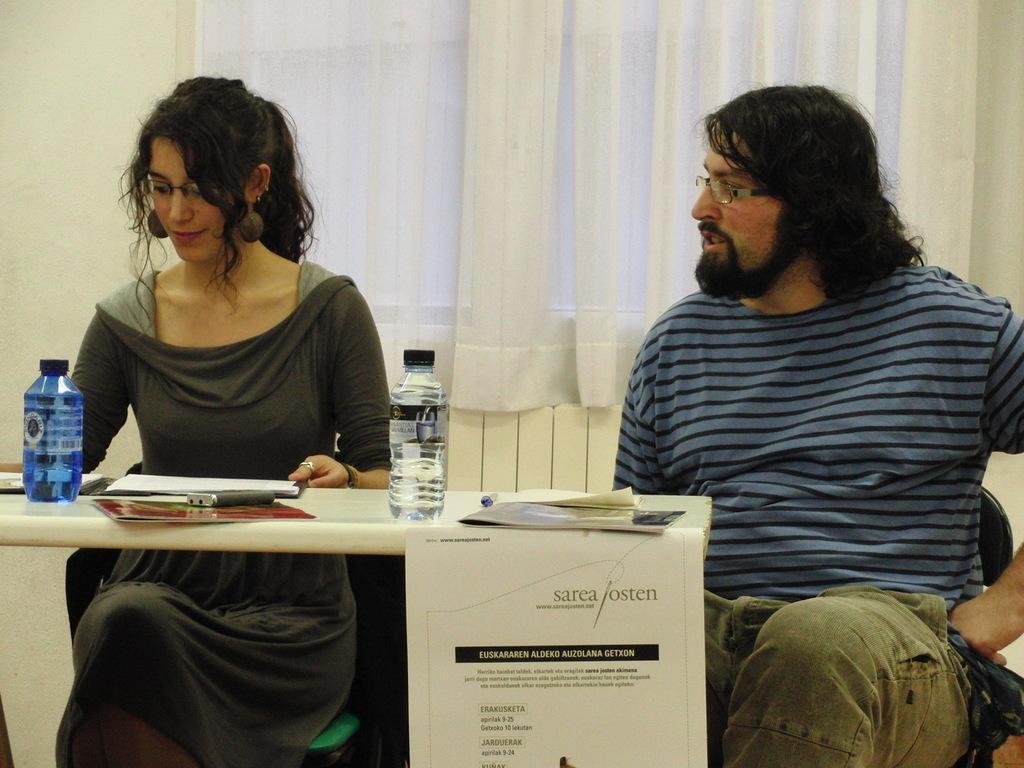How would you summarize this image in a sentence or two? The two persons are sitting on a chairs. There is a table. There is a bottle,paper and pen on a table. We can see in background curtain and window. 